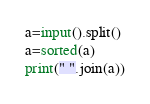Convert code to text. <code><loc_0><loc_0><loc_500><loc_500><_Python_>a=input().split()
a=sorted(a)
print(" ".join(a))
</code> 